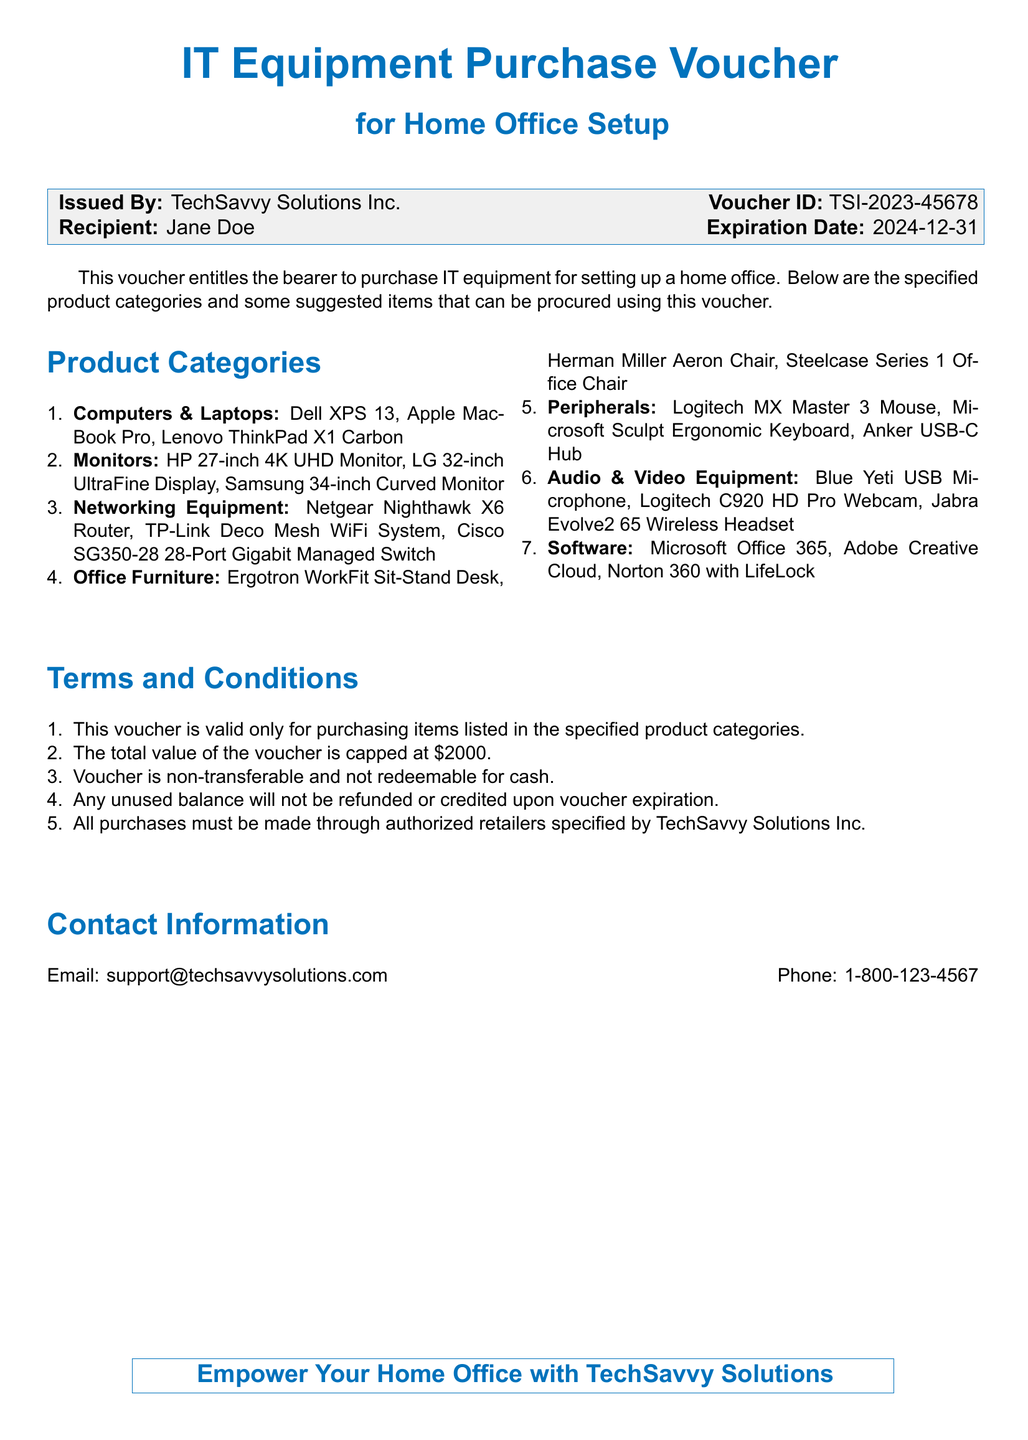What is the issuing company? The issuing company is specified in the document as TechSavvy Solutions Inc.
Answer: TechSavvy Solutions Inc What is the voucher ID? The voucher ID is a specific identifier given in the document, which is TSI-2023-45678.
Answer: TSI-2023-45678 Who is the recipient of the voucher? The recipient's name is mentioned in the document as Jane Doe.
Answer: Jane Doe What is the expiration date of the voucher? The expiration date is clearly stated in the document as 2024-12-31.
Answer: 2024-12-31 What is the total value of the voucher? The total value of the voucher is capped at a specific amount mentioned in the document, which is $2000.
Answer: $2000 Which category includes HP 27-inch 4K UHD Monitor? The HP 27-inch 4K UHD Monitor is listed under the Computers & Laptops category in the document.
Answer: Monitors What is one of the terms regarding the usage of the voucher? One of the terms states that the voucher cannot be redeemed for cash, as specified in the terms and conditions.
Answer: Non-transferable and not redeemable for cash Where can purchases be made using the voucher? The document specifies that all purchases must be made through authorized retailers, but it does not name specific ones.
Answer: Authorized retailers What type of equipment can be purchased using this voucher? The document specifies IT equipment for home office setup can be purchased with this voucher.
Answer: IT equipment 